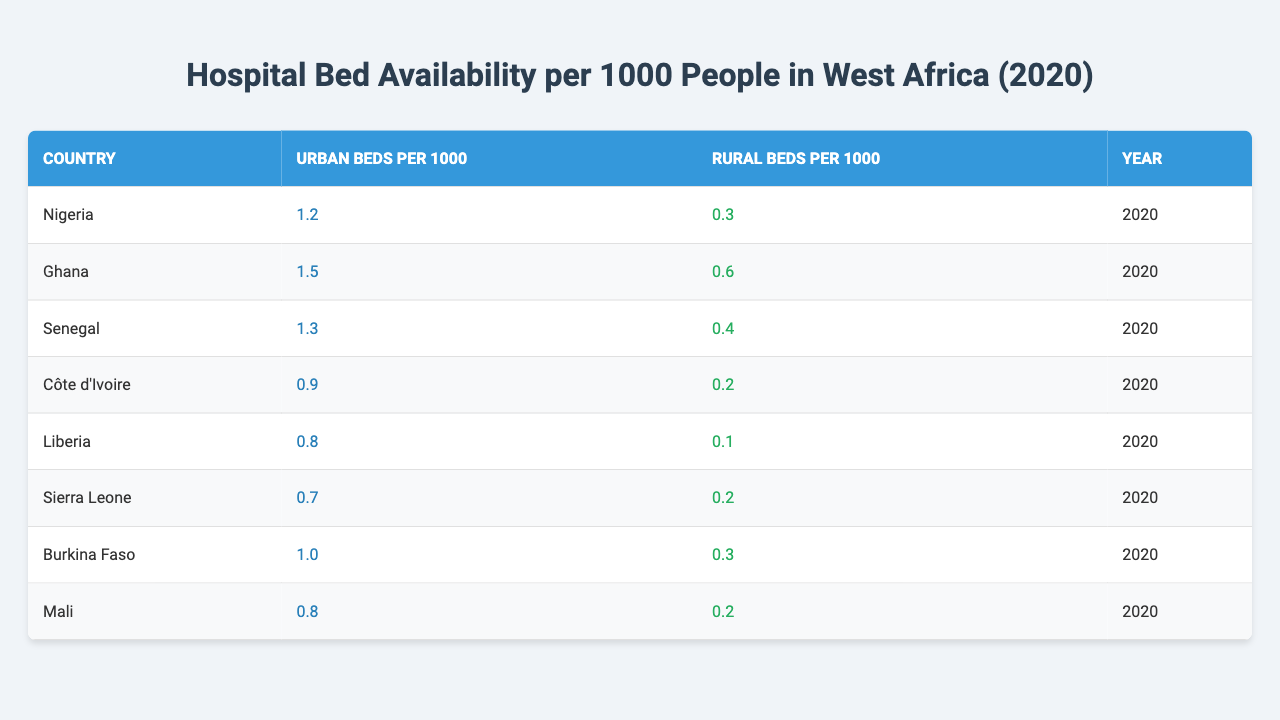What is the highest number of urban beds per 1000 people, and which country has it? From the table, Nigeria has 1.2 urban beds per 1000, which is the highest among the listed countries.
Answer: Nigeria, 1.2 How many rural beds per 1000 people does Côte d'Ivoire have? Côte d'Ivoire has 0.2 rural beds per 1000 people, as indicated in the table.
Answer: 0.2 Which country has the lowest number of urban beds per 1000 people? Sierra Leone has the lowest number with 0.7 urban beds per 1000 people.
Answer: Sierra Leone What is the difference in urban bed availability between Ghana and Liberia? Ghana has 1.5 urban beds per 1000, while Liberia has 0.8. The difference is 1.5 - 0.8 = 0.7.
Answer: 0.7 Is it true that Mali has more rural beds per 1000 than Côte d'Ivoire? No, Mali has 0.2 rural beds per 1000, which is not more than Côte d'Ivoire's 0.2; they are equal.
Answer: No What is the average number of rural beds per 1000 in the countries listed? The rural beds per 1000 are: 0.3 (Nigeria), 0.6 (Ghana), 0.4 (Senegal), 0.2 (Côte d'Ivoire), 0.1 (Liberia), 0.2 (Sierra Leone), 0.3 (Burkina Faso), and 0.2 (Mali), totaling 2.1. Dividing by 8 countries gives an average of 2.1 / 8 = 0.2625.
Answer: 0.2625 Which country has a higher count of urban beds per 1000 people, Senegal or Burkina Faso? Senegal has 1.3 urban beds per 1000 people, whereas Burkina Faso has 1.0. Since 1.3 is greater than 1.0, Senegal has a higher count.
Answer: Senegal How many countries have more than 1 urban bed per 1000 people? The countries with more than 1 urban bed per 1000 people are Nigeria (1.2), Ghana (1.5), and Senegal (1.3). Therefore, there are 3 such countries.
Answer: 3 What is the total number of urban beds per 1000 for all the countries combined? Adding the urban beds per 1000 provides: 1.2 + 1.5 + 1.3 + 0.9 + 0.8 + 0.7 + 1.0 + 0.8 = 8.2.
Answer: 8.2 